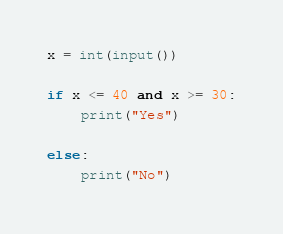Convert code to text. <code><loc_0><loc_0><loc_500><loc_500><_Python_>x = int(input())

if x <= 40 and x >= 30:
    print("Yes")

else:
    print("No")</code> 